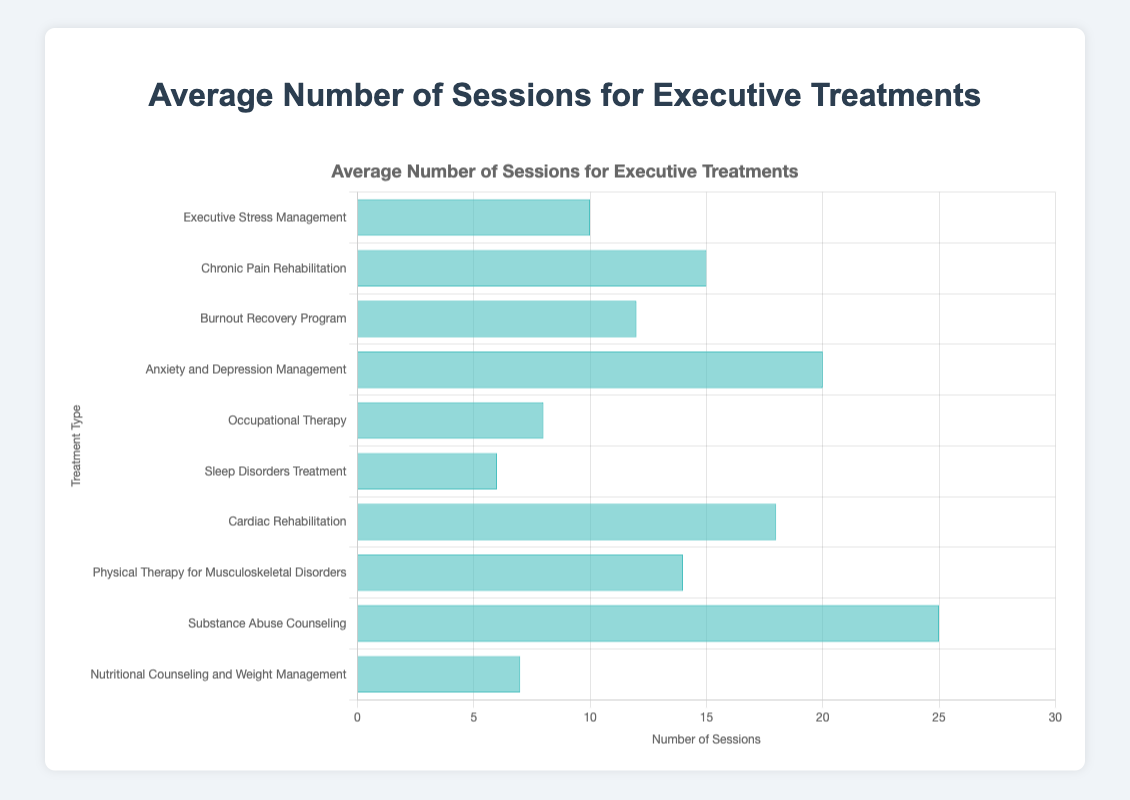Which treatment type requires the highest number of sessions? By inspecting the lengths of the bars in the horizontal bar chart, the longest bar represents the treatment type with the highest number of sessions. "Substance Abuse Counseling" has the longest bar at 25 sessions.
Answer: Substance Abuse Counseling Which treatment types require more than 15 sessions on average? To identify the treatment types with more than 15 sessions, look for bars that extend beyond the 15-session mark on the x-axis. "Anxiety and Depression Management", "Cardiac Rehabilitation", and "Substance Abuse Counseling" each require more than 15 sessions.
Answer: Anxiety and Depression Management, Cardiac Rehabilitation, Substance Abuse Counseling Which treatment types require fewer sessions on average: "Sleep Disorders Treatment" or "Nutritional Counseling and Weight Management"? Compare the lengths of the bars corresponding to "Sleep Disorders Treatment" and "Nutritional Counseling and Weight Management". "Sleep Disorders Treatment" requires 6 sessions, while "Nutritional Counseling and Weight Management" requires 7 sessions.
Answer: Sleep Disorders Treatment How many more sessions, on average, does "Chronic Pain Rehabilitation" require compared to "Occupational Therapy"? The bar for "Chronic Pain Rehabilitation" shows 15 sessions, and the bar for "Occupational Therapy" shows 8 sessions. Subtract 8 from 15 to get the difference.
Answer: 7 What is the average number of sessions required for "Executive Stress Management" and "Burnout Recovery Program" combined? Add the number of sessions for "Executive Stress Management" (10) and "Burnout Recovery Program" (12), then divide by 2 to find the average. (10 + 12) / 2 = 11.
Answer: 11 Which treatment types have bars that are the same length visually? By comparing the bars, "Occupational Therapy" (8 sessions) and "Nutritional Counseling and Weight Management" (7 sessions) have nearly the same length.
Answer: Occupational Therapy, Nutritional Counseling and Weight Management What is the total number of sessions required for "Physical Therapy for Musculoskeletal Disorders" and "Cardiac Rehabilitation"? Sum the sessions for "Physical Therapy for Musculoskeletal Disorders" (14) and "Cardiac Rehabilitation" (18). (14 + 18) = 32.
Answer: 32 What is the difference in the number of sessions between the treatment with the fewest and the one with the most sessions? The treatment with the fewest sessions is "Sleep Disorders Treatment" with 6 sessions, and the one with the most is "Substance Abuse Counseling" with 25 sessions. Subtract 6 from 25.
Answer: 19 Which treatment type requires the smallest number of sessions? By looking at the shortest bar in the chart, "Sleep Disorders Treatment" is identified with just 6 sessions.
Answer: Sleep Disorders Treatment 